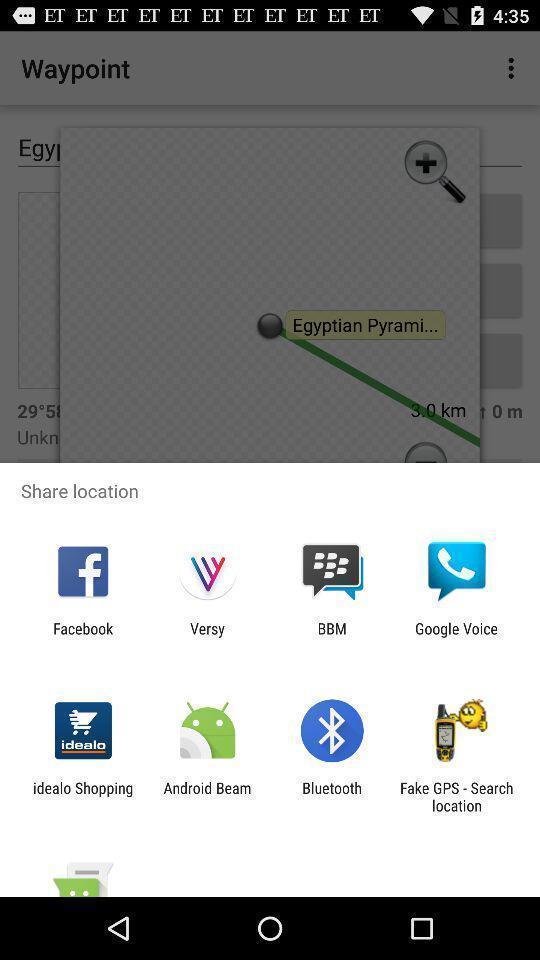Provide a detailed account of this screenshot. Share location page on an online maps. 